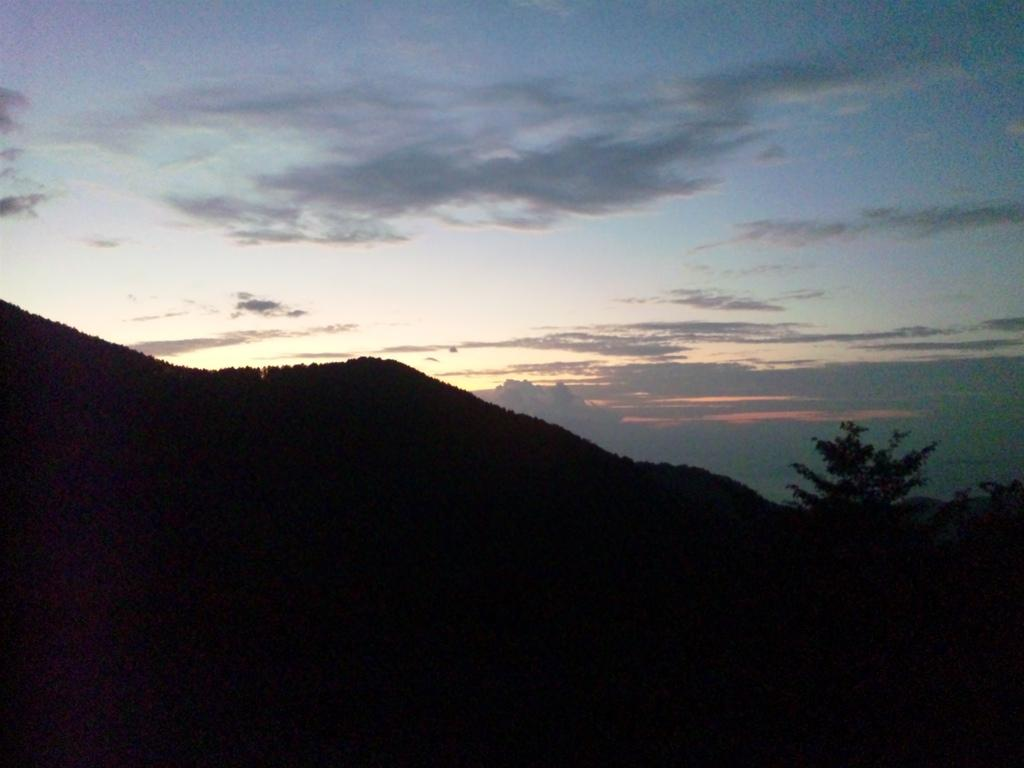What type of natural formation can be seen in the image? There are mountains in the image. Where is the tree located in the image? The tree is on the right side of the image. What is visible in the background of the image? The sky is visible in the background of the image. How many ants can be seen climbing the tree in the image? There are no ants present in the image. What color is the brain that is hanging from the tree in the image? There is no brain present in the image. 